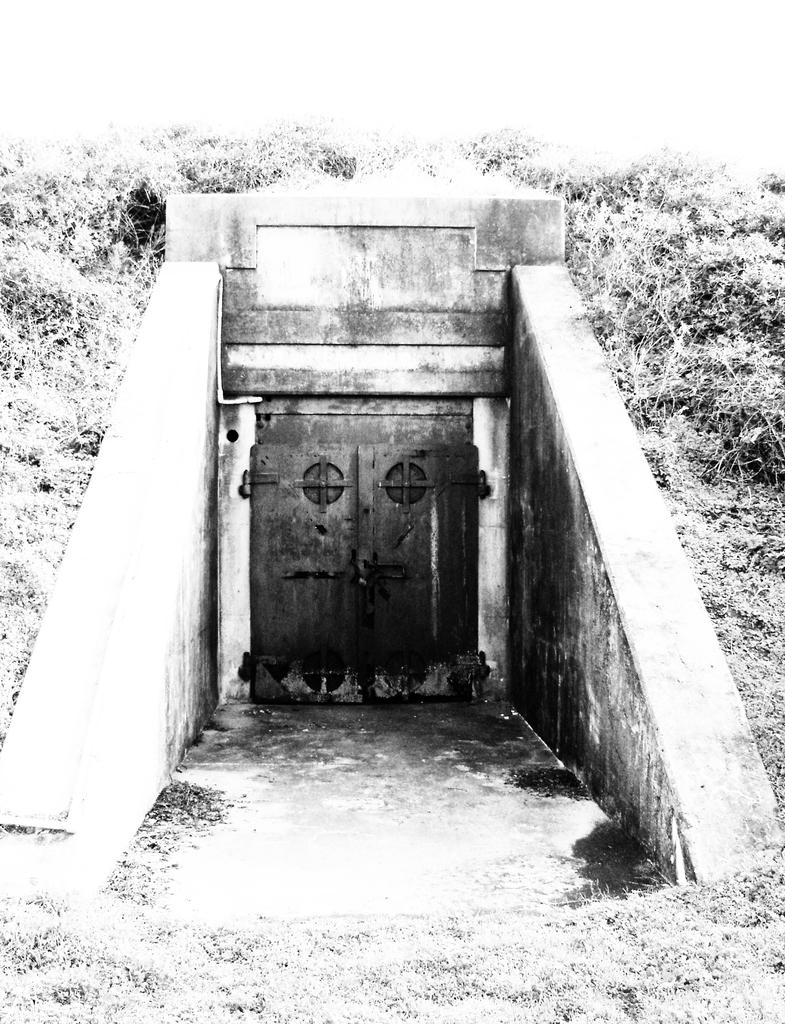What structure can be seen in the image? There is a door in the image. What type of vegetation is on the left side of the image? There are trees on the left side of the image. What type of vegetation is on the right side of the image? There are trees on the right side of the image. What type of ground surface is visible in the image? Grass is visible in the image. What is the color scheme of the image? The image is in black and white. What type of organization is depicted in the image? There is no organization depicted in the image; it features a door, trees, grass, and a black and white color scheme. Can you tell me how many clouds are visible in the image? There are no clouds visible in the image, as it is in black and white and does not include any sky elements. 